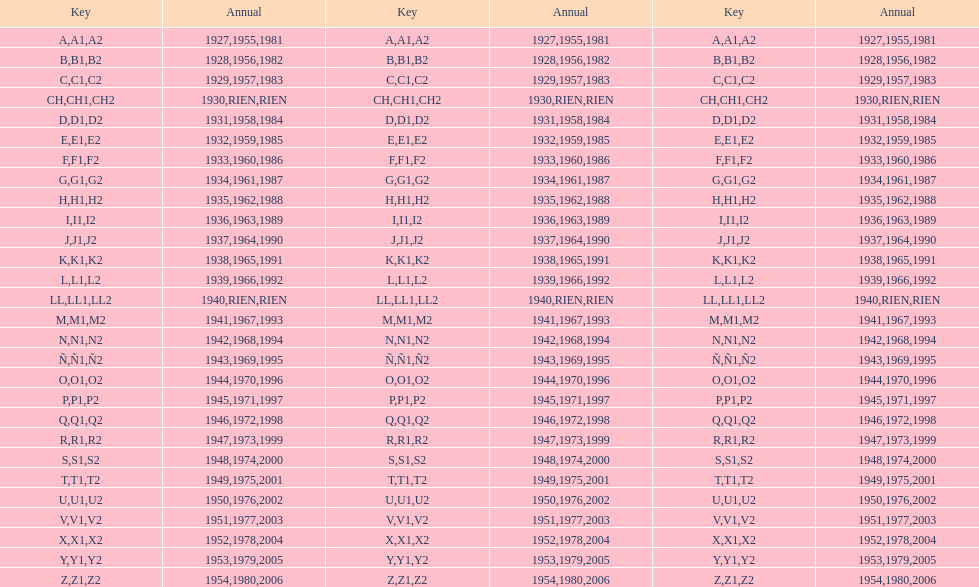Is the e code less than 1950? Yes. 